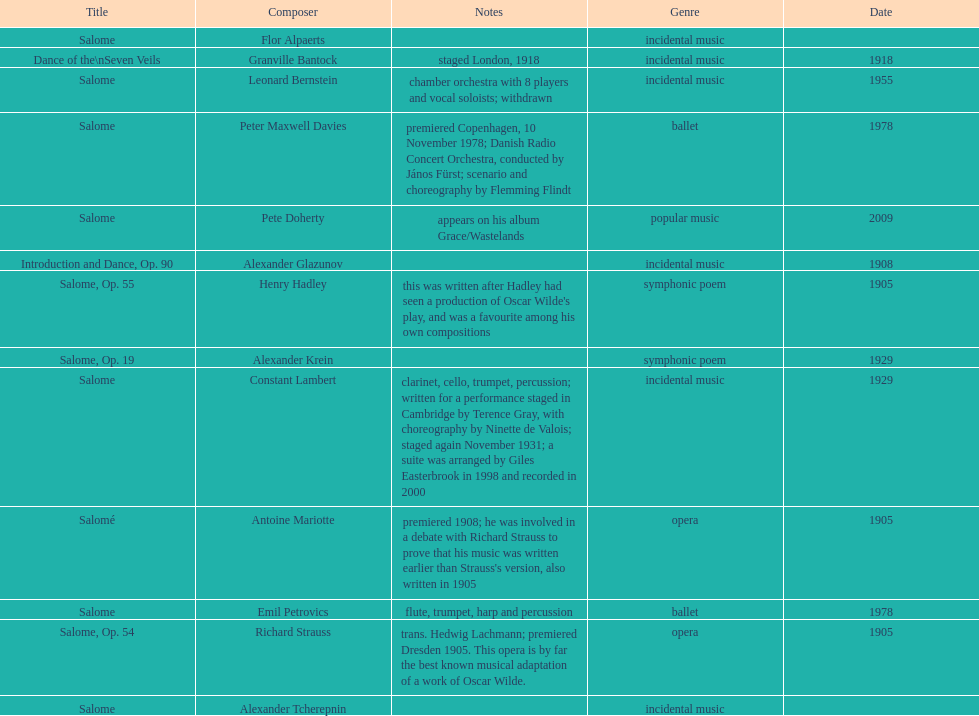Which composer produced his title after 2001? Pete Doherty. 